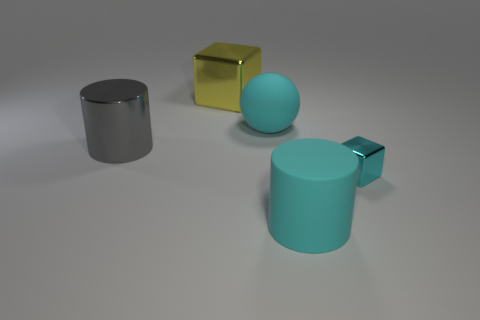Subtract all yellow balls. Subtract all green cylinders. How many balls are left? 1 Add 2 big blue matte balls. How many objects exist? 7 Subtract all cubes. How many objects are left? 3 Add 5 cyan metallic objects. How many cyan metallic objects exist? 6 Subtract 0 brown balls. How many objects are left? 5 Subtract all tiny gray shiny cylinders. Subtract all gray metal things. How many objects are left? 4 Add 4 big gray shiny cylinders. How many big gray shiny cylinders are left? 5 